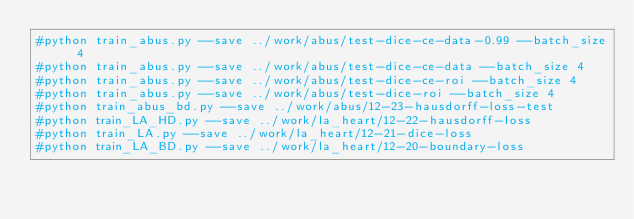<code> <loc_0><loc_0><loc_500><loc_500><_Bash_>#python train_abus.py --save ../work/abus/test-dice-ce-data-0.99 --batch_size 4
#python train_abus.py --save ../work/abus/test-dice-ce-data --batch_size 4
#python train_abus.py --save ../work/abus/test-dice-ce-roi --batch_size 4
#python train_abus.py --save ../work/abus/test-dice-roi --batch_size 4
#python train_abus_bd.py --save ../work/abus/12-23-hausdorff-loss-test
#python train_LA_HD.py --save ../work/la_heart/12-22-hausdorff-loss
#python train_LA.py --save ../work/la_heart/12-21-dice-loss
#python train_LA_BD.py --save ../work/la_heart/12-20-boundary-loss
</code> 